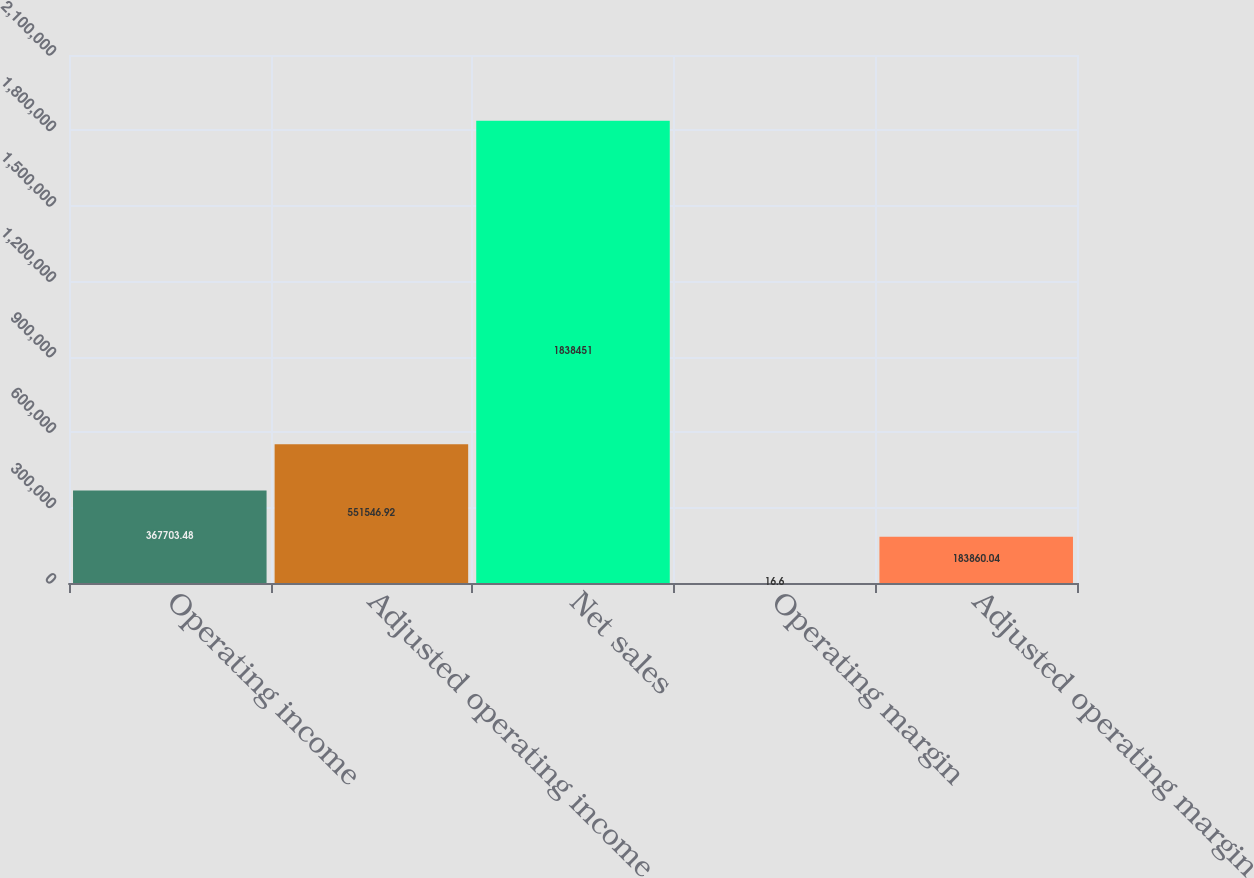<chart> <loc_0><loc_0><loc_500><loc_500><bar_chart><fcel>Operating income<fcel>Adjusted operating income<fcel>Net sales<fcel>Operating margin<fcel>Adjusted operating margin<nl><fcel>367703<fcel>551547<fcel>1.83845e+06<fcel>16.6<fcel>183860<nl></chart> 